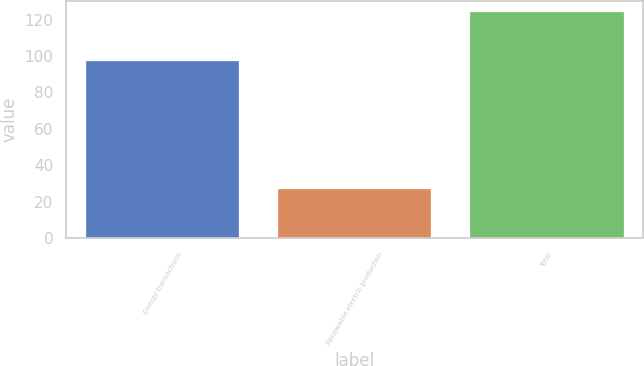Convert chart to OTSL. <chart><loc_0><loc_0><loc_500><loc_500><bar_chart><fcel>Energy transactions<fcel>Renewable electric production<fcel>Total<nl><fcel>97<fcel>27<fcel>124<nl></chart> 